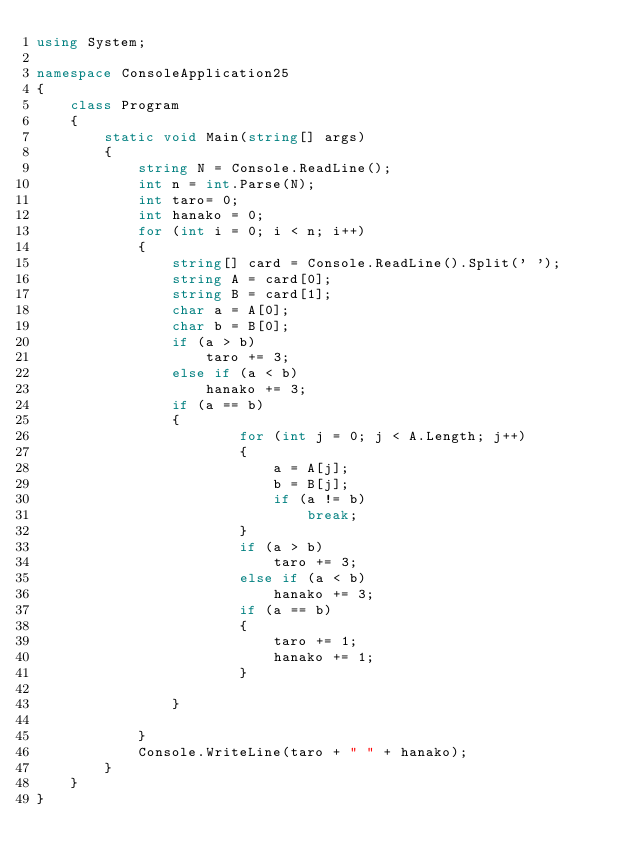Convert code to text. <code><loc_0><loc_0><loc_500><loc_500><_C#_>using System;

namespace ConsoleApplication25
{
    class Program
    {
        static void Main(string[] args)
        {
            string N = Console.ReadLine();
            int n = int.Parse(N);
            int taro= 0;
            int hanako = 0;
            for (int i = 0; i < n; i++)
            {
                string[] card = Console.ReadLine().Split(' ');
                string A = card[0];
                string B = card[1];
                char a = A[0];
                char b = B[0];
                if (a > b)
                    taro += 3;
                else if (a < b)
                    hanako += 3;
                if (a == b)
                {
                        for (int j = 0; j < A.Length; j++)
                        {
                            a = A[j];
                            b = B[j];
                            if (a != b)
                                break;
                        }
                        if (a > b)
                            taro += 3;
                        else if (a < b)
                            hanako += 3;
                        if (a == b)
                        {
                            taro += 1;
                            hanako += 1;
                        }
                            
                }

            }
            Console.WriteLine(taro + " " + hanako);
        }
    }
}</code> 